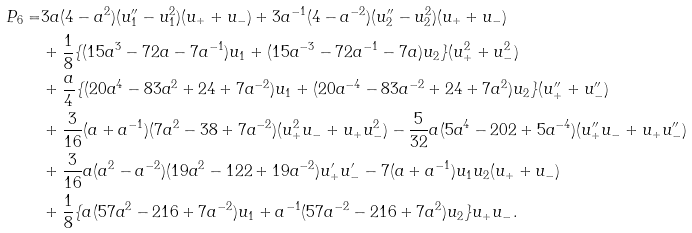Convert formula to latex. <formula><loc_0><loc_0><loc_500><loc_500>P _ { 6 } = & 3 a ( 4 - a ^ { 2 } ) ( u _ { 1 } ^ { \prime \prime } - u _ { 1 } ^ { 2 } ) ( u _ { + } + u _ { - } ) + 3 a ^ { - 1 } ( 4 - a ^ { - 2 } ) ( u _ { 2 } ^ { \prime \prime } - u _ { 2 } ^ { 2 } ) ( u _ { + } + u _ { - } ) \\ & + \frac { 1 } { 8 } \{ ( 1 5 a ^ { 3 } - 7 2 a - 7 a ^ { - 1 } ) u _ { 1 } + ( 1 5 a ^ { - 3 } - 7 2 a ^ { - 1 } - 7 a ) u _ { 2 } \} ( u _ { + } ^ { 2 } + u _ { - } ^ { 2 } ) \\ & + \frac { a } { 4 } \{ ( 2 0 a ^ { 4 } - 8 3 a ^ { 2 } + 2 4 + 7 a ^ { - 2 } ) u _ { 1 } + ( 2 0 a ^ { - 4 } - 8 3 a ^ { - 2 } + 2 4 + 7 a ^ { 2 } ) u _ { 2 } \} ( u _ { + } ^ { \prime \prime } + u _ { - } ^ { \prime \prime } ) \\ & + \frac { 3 } { 1 6 } ( a + a ^ { - 1 } ) ( 7 a ^ { 2 } - 3 8 + 7 a ^ { - 2 } ) ( u _ { + } ^ { 2 } u _ { - } + u _ { + } u _ { - } ^ { 2 } ) - \frac { 5 } { 3 2 } a ( 5 a ^ { 4 } - 2 0 2 + 5 a ^ { - 4 } ) ( u _ { + } ^ { \prime \prime } u _ { - } + u _ { + } u _ { - } ^ { \prime \prime } ) \\ & + \frac { 3 } { 1 6 } a ( a ^ { 2 } - a ^ { - 2 } ) ( 1 9 a ^ { 2 } - 1 2 2 + 1 9 a ^ { - 2 } ) u _ { + } ^ { \prime } u _ { - } ^ { \prime } - 7 ( a + a ^ { - 1 } ) u _ { 1 } u _ { 2 } ( u _ { + } + u _ { - } ) \\ & + \frac { 1 } { 8 } \{ a ( 5 7 a ^ { 2 } - 2 1 6 + 7 a ^ { - 2 } ) u _ { 1 } + a ^ { - 1 } ( 5 7 a ^ { - 2 } - 2 1 6 + 7 a ^ { 2 } ) u _ { 2 } \} u _ { + } u _ { - } .</formula> 